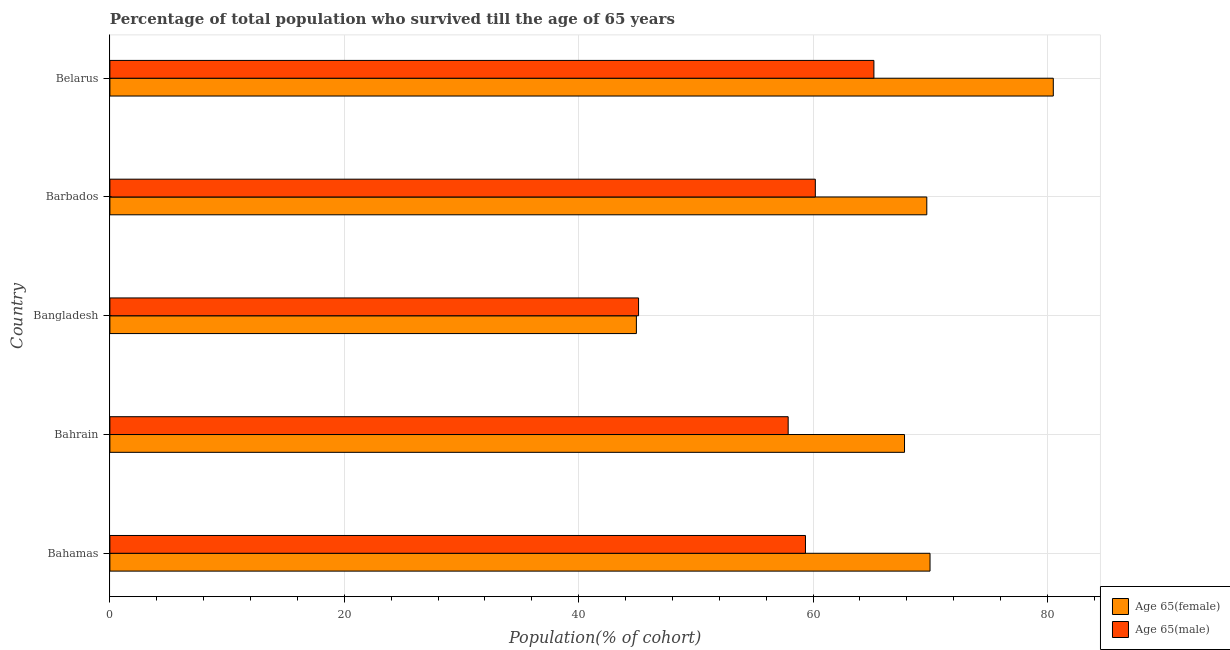What is the label of the 2nd group of bars from the top?
Offer a terse response. Barbados. What is the percentage of male population who survived till age of 65 in Bahamas?
Give a very brief answer. 59.35. Across all countries, what is the maximum percentage of female population who survived till age of 65?
Offer a very short reply. 80.5. Across all countries, what is the minimum percentage of male population who survived till age of 65?
Your response must be concise. 45.11. In which country was the percentage of female population who survived till age of 65 maximum?
Give a very brief answer. Belarus. What is the total percentage of female population who survived till age of 65 in the graph?
Offer a terse response. 332.91. What is the difference between the percentage of female population who survived till age of 65 in Bahamas and that in Bangladesh?
Your response must be concise. 25.05. What is the difference between the percentage of female population who survived till age of 65 in Bangladesh and the percentage of male population who survived till age of 65 in Barbados?
Provide a succinct answer. -15.27. What is the average percentage of female population who survived till age of 65 per country?
Provide a succinct answer. 66.58. What is the difference between the percentage of female population who survived till age of 65 and percentage of male population who survived till age of 65 in Bahrain?
Offer a terse response. 9.93. What is the ratio of the percentage of female population who survived till age of 65 in Bahamas to that in Barbados?
Ensure brevity in your answer.  1. Is the percentage of male population who survived till age of 65 in Bangladesh less than that in Barbados?
Offer a terse response. Yes. What is the difference between the highest and the second highest percentage of female population who survived till age of 65?
Make the answer very short. 10.52. What is the difference between the highest and the lowest percentage of male population who survived till age of 65?
Your response must be concise. 20.08. In how many countries, is the percentage of female population who survived till age of 65 greater than the average percentage of female population who survived till age of 65 taken over all countries?
Your response must be concise. 4. Is the sum of the percentage of male population who survived till age of 65 in Bahamas and Belarus greater than the maximum percentage of female population who survived till age of 65 across all countries?
Make the answer very short. Yes. What does the 1st bar from the top in Bangladesh represents?
Provide a succinct answer. Age 65(male). What does the 1st bar from the bottom in Bangladesh represents?
Offer a terse response. Age 65(female). How many bars are there?
Provide a short and direct response. 10. Are all the bars in the graph horizontal?
Keep it short and to the point. Yes. How many countries are there in the graph?
Give a very brief answer. 5. Does the graph contain grids?
Make the answer very short. Yes. How many legend labels are there?
Provide a succinct answer. 2. What is the title of the graph?
Provide a succinct answer. Percentage of total population who survived till the age of 65 years. What is the label or title of the X-axis?
Make the answer very short. Population(% of cohort). What is the label or title of the Y-axis?
Give a very brief answer. Country. What is the Population(% of cohort) in Age 65(female) in Bahamas?
Keep it short and to the point. 69.98. What is the Population(% of cohort) in Age 65(male) in Bahamas?
Provide a succinct answer. 59.35. What is the Population(% of cohort) of Age 65(female) in Bahrain?
Provide a short and direct response. 67.8. What is the Population(% of cohort) of Age 65(male) in Bahrain?
Make the answer very short. 57.88. What is the Population(% of cohort) of Age 65(female) in Bangladesh?
Your answer should be very brief. 44.92. What is the Population(% of cohort) in Age 65(male) in Bangladesh?
Offer a very short reply. 45.11. What is the Population(% of cohort) of Age 65(female) in Barbados?
Your answer should be compact. 69.7. What is the Population(% of cohort) of Age 65(male) in Barbados?
Your answer should be compact. 60.19. What is the Population(% of cohort) in Age 65(female) in Belarus?
Make the answer very short. 80.5. What is the Population(% of cohort) in Age 65(male) in Belarus?
Provide a short and direct response. 65.19. Across all countries, what is the maximum Population(% of cohort) in Age 65(female)?
Give a very brief answer. 80.5. Across all countries, what is the maximum Population(% of cohort) in Age 65(male)?
Keep it short and to the point. 65.19. Across all countries, what is the minimum Population(% of cohort) of Age 65(female)?
Ensure brevity in your answer.  44.92. Across all countries, what is the minimum Population(% of cohort) in Age 65(male)?
Provide a succinct answer. 45.11. What is the total Population(% of cohort) in Age 65(female) in the graph?
Offer a terse response. 332.91. What is the total Population(% of cohort) in Age 65(male) in the graph?
Offer a very short reply. 287.72. What is the difference between the Population(% of cohort) of Age 65(female) in Bahamas and that in Bahrain?
Your answer should be compact. 2.18. What is the difference between the Population(% of cohort) in Age 65(male) in Bahamas and that in Bahrain?
Offer a terse response. 1.48. What is the difference between the Population(% of cohort) in Age 65(female) in Bahamas and that in Bangladesh?
Offer a very short reply. 25.06. What is the difference between the Population(% of cohort) in Age 65(male) in Bahamas and that in Bangladesh?
Offer a terse response. 14.24. What is the difference between the Population(% of cohort) in Age 65(female) in Bahamas and that in Barbados?
Keep it short and to the point. 0.28. What is the difference between the Population(% of cohort) of Age 65(male) in Bahamas and that in Barbados?
Give a very brief answer. -0.84. What is the difference between the Population(% of cohort) in Age 65(female) in Bahamas and that in Belarus?
Your answer should be compact. -10.52. What is the difference between the Population(% of cohort) of Age 65(male) in Bahamas and that in Belarus?
Provide a succinct answer. -5.84. What is the difference between the Population(% of cohort) in Age 65(female) in Bahrain and that in Bangladesh?
Offer a terse response. 22.88. What is the difference between the Population(% of cohort) of Age 65(male) in Bahrain and that in Bangladesh?
Your response must be concise. 12.77. What is the difference between the Population(% of cohort) in Age 65(female) in Bahrain and that in Barbados?
Your answer should be very brief. -1.9. What is the difference between the Population(% of cohort) in Age 65(male) in Bahrain and that in Barbados?
Make the answer very short. -2.32. What is the difference between the Population(% of cohort) of Age 65(female) in Bahrain and that in Belarus?
Offer a very short reply. -12.69. What is the difference between the Population(% of cohort) in Age 65(male) in Bahrain and that in Belarus?
Offer a terse response. -7.32. What is the difference between the Population(% of cohort) of Age 65(female) in Bangladesh and that in Barbados?
Keep it short and to the point. -24.78. What is the difference between the Population(% of cohort) in Age 65(male) in Bangladesh and that in Barbados?
Your answer should be compact. -15.08. What is the difference between the Population(% of cohort) of Age 65(female) in Bangladesh and that in Belarus?
Provide a succinct answer. -35.57. What is the difference between the Population(% of cohort) in Age 65(male) in Bangladesh and that in Belarus?
Provide a succinct answer. -20.08. What is the difference between the Population(% of cohort) in Age 65(female) in Barbados and that in Belarus?
Offer a very short reply. -10.79. What is the difference between the Population(% of cohort) of Age 65(male) in Barbados and that in Belarus?
Provide a short and direct response. -5. What is the difference between the Population(% of cohort) in Age 65(female) in Bahamas and the Population(% of cohort) in Age 65(male) in Bahrain?
Ensure brevity in your answer.  12.1. What is the difference between the Population(% of cohort) of Age 65(female) in Bahamas and the Population(% of cohort) of Age 65(male) in Bangladesh?
Keep it short and to the point. 24.87. What is the difference between the Population(% of cohort) of Age 65(female) in Bahamas and the Population(% of cohort) of Age 65(male) in Barbados?
Your answer should be very brief. 9.79. What is the difference between the Population(% of cohort) in Age 65(female) in Bahamas and the Population(% of cohort) in Age 65(male) in Belarus?
Make the answer very short. 4.79. What is the difference between the Population(% of cohort) in Age 65(female) in Bahrain and the Population(% of cohort) in Age 65(male) in Bangladesh?
Your response must be concise. 22.69. What is the difference between the Population(% of cohort) of Age 65(female) in Bahrain and the Population(% of cohort) of Age 65(male) in Barbados?
Give a very brief answer. 7.61. What is the difference between the Population(% of cohort) of Age 65(female) in Bahrain and the Population(% of cohort) of Age 65(male) in Belarus?
Provide a short and direct response. 2.61. What is the difference between the Population(% of cohort) of Age 65(female) in Bangladesh and the Population(% of cohort) of Age 65(male) in Barbados?
Your answer should be very brief. -15.27. What is the difference between the Population(% of cohort) in Age 65(female) in Bangladesh and the Population(% of cohort) in Age 65(male) in Belarus?
Your answer should be compact. -20.27. What is the difference between the Population(% of cohort) in Age 65(female) in Barbados and the Population(% of cohort) in Age 65(male) in Belarus?
Keep it short and to the point. 4.51. What is the average Population(% of cohort) in Age 65(female) per country?
Provide a short and direct response. 66.58. What is the average Population(% of cohort) in Age 65(male) per country?
Offer a very short reply. 57.54. What is the difference between the Population(% of cohort) of Age 65(female) and Population(% of cohort) of Age 65(male) in Bahamas?
Your response must be concise. 10.63. What is the difference between the Population(% of cohort) in Age 65(female) and Population(% of cohort) in Age 65(male) in Bahrain?
Keep it short and to the point. 9.93. What is the difference between the Population(% of cohort) in Age 65(female) and Population(% of cohort) in Age 65(male) in Bangladesh?
Your response must be concise. -0.19. What is the difference between the Population(% of cohort) in Age 65(female) and Population(% of cohort) in Age 65(male) in Barbados?
Offer a terse response. 9.51. What is the difference between the Population(% of cohort) of Age 65(female) and Population(% of cohort) of Age 65(male) in Belarus?
Your answer should be very brief. 15.31. What is the ratio of the Population(% of cohort) in Age 65(female) in Bahamas to that in Bahrain?
Your answer should be compact. 1.03. What is the ratio of the Population(% of cohort) in Age 65(male) in Bahamas to that in Bahrain?
Your answer should be very brief. 1.03. What is the ratio of the Population(% of cohort) of Age 65(female) in Bahamas to that in Bangladesh?
Your answer should be very brief. 1.56. What is the ratio of the Population(% of cohort) of Age 65(male) in Bahamas to that in Bangladesh?
Provide a succinct answer. 1.32. What is the ratio of the Population(% of cohort) of Age 65(male) in Bahamas to that in Barbados?
Make the answer very short. 0.99. What is the ratio of the Population(% of cohort) of Age 65(female) in Bahamas to that in Belarus?
Give a very brief answer. 0.87. What is the ratio of the Population(% of cohort) of Age 65(male) in Bahamas to that in Belarus?
Give a very brief answer. 0.91. What is the ratio of the Population(% of cohort) of Age 65(female) in Bahrain to that in Bangladesh?
Ensure brevity in your answer.  1.51. What is the ratio of the Population(% of cohort) of Age 65(male) in Bahrain to that in Bangladesh?
Your answer should be compact. 1.28. What is the ratio of the Population(% of cohort) in Age 65(female) in Bahrain to that in Barbados?
Your answer should be compact. 0.97. What is the ratio of the Population(% of cohort) in Age 65(male) in Bahrain to that in Barbados?
Provide a succinct answer. 0.96. What is the ratio of the Population(% of cohort) of Age 65(female) in Bahrain to that in Belarus?
Your answer should be very brief. 0.84. What is the ratio of the Population(% of cohort) of Age 65(male) in Bahrain to that in Belarus?
Provide a short and direct response. 0.89. What is the ratio of the Population(% of cohort) of Age 65(female) in Bangladesh to that in Barbados?
Give a very brief answer. 0.64. What is the ratio of the Population(% of cohort) of Age 65(male) in Bangladesh to that in Barbados?
Ensure brevity in your answer.  0.75. What is the ratio of the Population(% of cohort) of Age 65(female) in Bangladesh to that in Belarus?
Give a very brief answer. 0.56. What is the ratio of the Population(% of cohort) of Age 65(male) in Bangladesh to that in Belarus?
Ensure brevity in your answer.  0.69. What is the ratio of the Population(% of cohort) in Age 65(female) in Barbados to that in Belarus?
Ensure brevity in your answer.  0.87. What is the ratio of the Population(% of cohort) of Age 65(male) in Barbados to that in Belarus?
Provide a short and direct response. 0.92. What is the difference between the highest and the second highest Population(% of cohort) of Age 65(female)?
Give a very brief answer. 10.52. What is the difference between the highest and the second highest Population(% of cohort) in Age 65(male)?
Keep it short and to the point. 5. What is the difference between the highest and the lowest Population(% of cohort) of Age 65(female)?
Ensure brevity in your answer.  35.57. What is the difference between the highest and the lowest Population(% of cohort) of Age 65(male)?
Offer a very short reply. 20.08. 